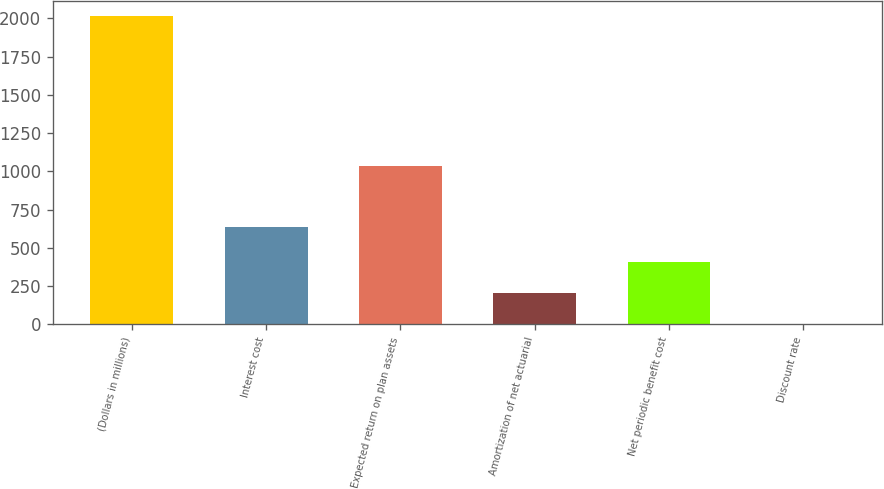Convert chart. <chart><loc_0><loc_0><loc_500><loc_500><bar_chart><fcel>(Dollars in millions)<fcel>Interest cost<fcel>Expected return on plan assets<fcel>Amortization of net actuarial<fcel>Net periodic benefit cost<fcel>Discount rate<nl><fcel>2016<fcel>634<fcel>1038<fcel>205.66<fcel>406.81<fcel>4.51<nl></chart> 